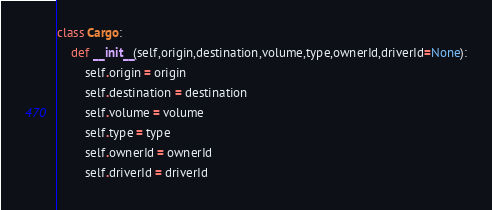<code> <loc_0><loc_0><loc_500><loc_500><_Python_>
class Cargo:
    def __init__(self,origin,destination,volume,type,ownerId,driverId=None):
        self.origin = origin
        self.destination = destination
        self.volume = volume
        self.type = type
        self.ownerId = ownerId
        self.driverId = driverId

</code> 